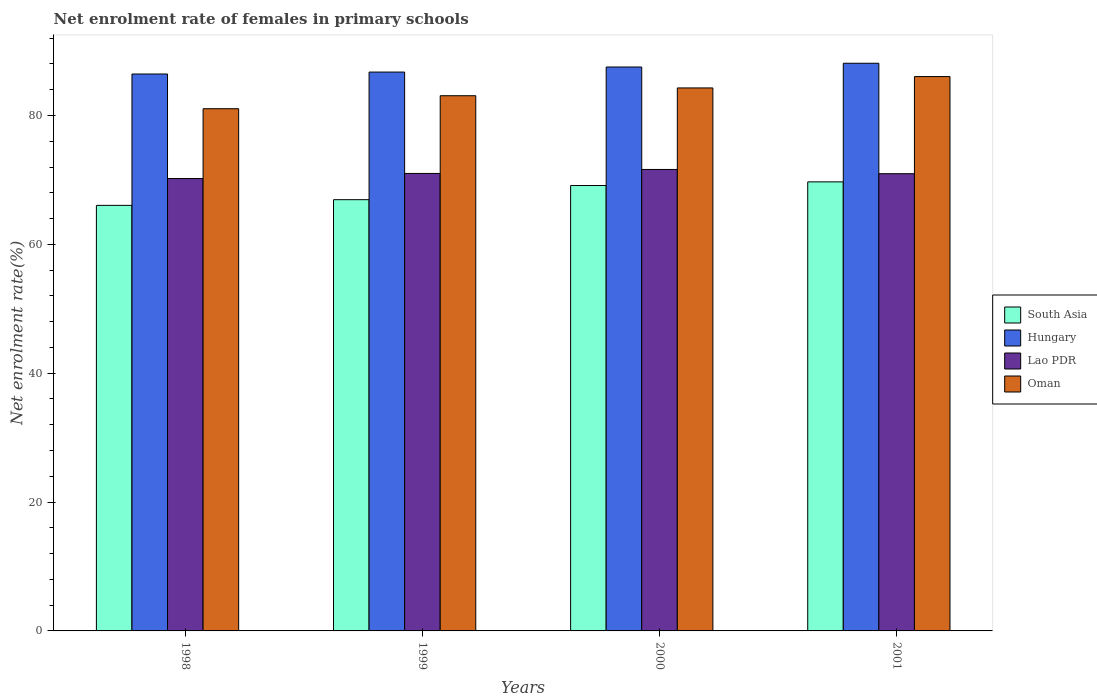How many groups of bars are there?
Keep it short and to the point. 4. Are the number of bars per tick equal to the number of legend labels?
Your response must be concise. Yes. How many bars are there on the 4th tick from the right?
Make the answer very short. 4. What is the label of the 3rd group of bars from the left?
Provide a short and direct response. 2000. In how many cases, is the number of bars for a given year not equal to the number of legend labels?
Your answer should be very brief. 0. What is the net enrolment rate of females in primary schools in Lao PDR in 2000?
Give a very brief answer. 71.62. Across all years, what is the maximum net enrolment rate of females in primary schools in South Asia?
Provide a short and direct response. 69.69. Across all years, what is the minimum net enrolment rate of females in primary schools in Hungary?
Keep it short and to the point. 86.43. What is the total net enrolment rate of females in primary schools in Oman in the graph?
Keep it short and to the point. 334.42. What is the difference between the net enrolment rate of females in primary schools in Oman in 1999 and that in 2001?
Your answer should be compact. -2.97. What is the difference between the net enrolment rate of females in primary schools in Oman in 2000 and the net enrolment rate of females in primary schools in Lao PDR in 1999?
Keep it short and to the point. 13.27. What is the average net enrolment rate of females in primary schools in South Asia per year?
Your answer should be very brief. 67.95. In the year 2000, what is the difference between the net enrolment rate of females in primary schools in Lao PDR and net enrolment rate of females in primary schools in Hungary?
Ensure brevity in your answer.  -15.9. In how many years, is the net enrolment rate of females in primary schools in Oman greater than 36 %?
Your answer should be compact. 4. What is the ratio of the net enrolment rate of females in primary schools in Hungary in 1998 to that in 2000?
Ensure brevity in your answer.  0.99. Is the net enrolment rate of females in primary schools in Lao PDR in 2000 less than that in 2001?
Offer a very short reply. No. What is the difference between the highest and the second highest net enrolment rate of females in primary schools in Hungary?
Provide a short and direct response. 0.58. What is the difference between the highest and the lowest net enrolment rate of females in primary schools in Oman?
Your answer should be compact. 4.99. Is it the case that in every year, the sum of the net enrolment rate of females in primary schools in Lao PDR and net enrolment rate of females in primary schools in Oman is greater than the sum of net enrolment rate of females in primary schools in South Asia and net enrolment rate of females in primary schools in Hungary?
Offer a very short reply. No. What does the 4th bar from the left in 2000 represents?
Give a very brief answer. Oman. What does the 2nd bar from the right in 2000 represents?
Ensure brevity in your answer.  Lao PDR. Are all the bars in the graph horizontal?
Ensure brevity in your answer.  No. How many years are there in the graph?
Ensure brevity in your answer.  4. What is the difference between two consecutive major ticks on the Y-axis?
Make the answer very short. 20. Are the values on the major ticks of Y-axis written in scientific E-notation?
Offer a terse response. No. Does the graph contain any zero values?
Give a very brief answer. No. Does the graph contain grids?
Ensure brevity in your answer.  No. Where does the legend appear in the graph?
Offer a very short reply. Center right. How many legend labels are there?
Offer a very short reply. 4. How are the legend labels stacked?
Offer a terse response. Vertical. What is the title of the graph?
Keep it short and to the point. Net enrolment rate of females in primary schools. Does "Albania" appear as one of the legend labels in the graph?
Offer a terse response. No. What is the label or title of the X-axis?
Make the answer very short. Years. What is the label or title of the Y-axis?
Your answer should be compact. Net enrolment rate(%). What is the Net enrolment rate(%) of South Asia in 1998?
Your answer should be compact. 66.05. What is the Net enrolment rate(%) in Hungary in 1998?
Give a very brief answer. 86.43. What is the Net enrolment rate(%) in Lao PDR in 1998?
Offer a very short reply. 70.21. What is the Net enrolment rate(%) of Oman in 1998?
Provide a short and direct response. 81.05. What is the Net enrolment rate(%) in South Asia in 1999?
Ensure brevity in your answer.  66.93. What is the Net enrolment rate(%) in Hungary in 1999?
Offer a terse response. 86.73. What is the Net enrolment rate(%) in Lao PDR in 1999?
Your answer should be compact. 71. What is the Net enrolment rate(%) of Oman in 1999?
Ensure brevity in your answer.  83.06. What is the Net enrolment rate(%) of South Asia in 2000?
Keep it short and to the point. 69.13. What is the Net enrolment rate(%) of Hungary in 2000?
Provide a short and direct response. 87.52. What is the Net enrolment rate(%) in Lao PDR in 2000?
Provide a short and direct response. 71.62. What is the Net enrolment rate(%) in Oman in 2000?
Ensure brevity in your answer.  84.27. What is the Net enrolment rate(%) in South Asia in 2001?
Offer a terse response. 69.69. What is the Net enrolment rate(%) of Hungary in 2001?
Offer a very short reply. 88.1. What is the Net enrolment rate(%) in Lao PDR in 2001?
Your response must be concise. 70.96. What is the Net enrolment rate(%) of Oman in 2001?
Provide a short and direct response. 86.04. Across all years, what is the maximum Net enrolment rate(%) in South Asia?
Make the answer very short. 69.69. Across all years, what is the maximum Net enrolment rate(%) in Hungary?
Your answer should be very brief. 88.1. Across all years, what is the maximum Net enrolment rate(%) in Lao PDR?
Ensure brevity in your answer.  71.62. Across all years, what is the maximum Net enrolment rate(%) in Oman?
Give a very brief answer. 86.04. Across all years, what is the minimum Net enrolment rate(%) in South Asia?
Keep it short and to the point. 66.05. Across all years, what is the minimum Net enrolment rate(%) in Hungary?
Give a very brief answer. 86.43. Across all years, what is the minimum Net enrolment rate(%) of Lao PDR?
Ensure brevity in your answer.  70.21. Across all years, what is the minimum Net enrolment rate(%) of Oman?
Make the answer very short. 81.05. What is the total Net enrolment rate(%) of South Asia in the graph?
Offer a very short reply. 271.79. What is the total Net enrolment rate(%) of Hungary in the graph?
Make the answer very short. 348.79. What is the total Net enrolment rate(%) in Lao PDR in the graph?
Your answer should be compact. 283.79. What is the total Net enrolment rate(%) in Oman in the graph?
Provide a short and direct response. 334.42. What is the difference between the Net enrolment rate(%) of South Asia in 1998 and that in 1999?
Ensure brevity in your answer.  -0.88. What is the difference between the Net enrolment rate(%) of Hungary in 1998 and that in 1999?
Give a very brief answer. -0.3. What is the difference between the Net enrolment rate(%) in Lao PDR in 1998 and that in 1999?
Give a very brief answer. -0.79. What is the difference between the Net enrolment rate(%) of Oman in 1998 and that in 1999?
Offer a terse response. -2.02. What is the difference between the Net enrolment rate(%) of South Asia in 1998 and that in 2000?
Keep it short and to the point. -3.08. What is the difference between the Net enrolment rate(%) in Hungary in 1998 and that in 2000?
Your response must be concise. -1.09. What is the difference between the Net enrolment rate(%) in Lao PDR in 1998 and that in 2000?
Your response must be concise. -1.4. What is the difference between the Net enrolment rate(%) in Oman in 1998 and that in 2000?
Make the answer very short. -3.23. What is the difference between the Net enrolment rate(%) of South Asia in 1998 and that in 2001?
Make the answer very short. -3.65. What is the difference between the Net enrolment rate(%) of Hungary in 1998 and that in 2001?
Ensure brevity in your answer.  -1.67. What is the difference between the Net enrolment rate(%) of Lao PDR in 1998 and that in 2001?
Make the answer very short. -0.75. What is the difference between the Net enrolment rate(%) in Oman in 1998 and that in 2001?
Offer a terse response. -4.99. What is the difference between the Net enrolment rate(%) in South Asia in 1999 and that in 2000?
Offer a terse response. -2.2. What is the difference between the Net enrolment rate(%) in Hungary in 1999 and that in 2000?
Your answer should be compact. -0.79. What is the difference between the Net enrolment rate(%) in Lao PDR in 1999 and that in 2000?
Your answer should be very brief. -0.62. What is the difference between the Net enrolment rate(%) in Oman in 1999 and that in 2000?
Keep it short and to the point. -1.21. What is the difference between the Net enrolment rate(%) in South Asia in 1999 and that in 2001?
Your answer should be very brief. -2.76. What is the difference between the Net enrolment rate(%) in Hungary in 1999 and that in 2001?
Make the answer very short. -1.37. What is the difference between the Net enrolment rate(%) of Lao PDR in 1999 and that in 2001?
Provide a succinct answer. 0.04. What is the difference between the Net enrolment rate(%) of Oman in 1999 and that in 2001?
Offer a very short reply. -2.97. What is the difference between the Net enrolment rate(%) of South Asia in 2000 and that in 2001?
Provide a short and direct response. -0.57. What is the difference between the Net enrolment rate(%) of Hungary in 2000 and that in 2001?
Keep it short and to the point. -0.58. What is the difference between the Net enrolment rate(%) in Lao PDR in 2000 and that in 2001?
Your answer should be very brief. 0.66. What is the difference between the Net enrolment rate(%) of Oman in 2000 and that in 2001?
Your answer should be very brief. -1.76. What is the difference between the Net enrolment rate(%) of South Asia in 1998 and the Net enrolment rate(%) of Hungary in 1999?
Offer a very short reply. -20.69. What is the difference between the Net enrolment rate(%) in South Asia in 1998 and the Net enrolment rate(%) in Lao PDR in 1999?
Your answer should be very brief. -4.96. What is the difference between the Net enrolment rate(%) of South Asia in 1998 and the Net enrolment rate(%) of Oman in 1999?
Offer a terse response. -17.02. What is the difference between the Net enrolment rate(%) of Hungary in 1998 and the Net enrolment rate(%) of Lao PDR in 1999?
Provide a short and direct response. 15.43. What is the difference between the Net enrolment rate(%) in Hungary in 1998 and the Net enrolment rate(%) in Oman in 1999?
Provide a succinct answer. 3.37. What is the difference between the Net enrolment rate(%) of Lao PDR in 1998 and the Net enrolment rate(%) of Oman in 1999?
Ensure brevity in your answer.  -12.85. What is the difference between the Net enrolment rate(%) of South Asia in 1998 and the Net enrolment rate(%) of Hungary in 2000?
Offer a terse response. -21.47. What is the difference between the Net enrolment rate(%) of South Asia in 1998 and the Net enrolment rate(%) of Lao PDR in 2000?
Make the answer very short. -5.57. What is the difference between the Net enrolment rate(%) in South Asia in 1998 and the Net enrolment rate(%) in Oman in 2000?
Give a very brief answer. -18.23. What is the difference between the Net enrolment rate(%) in Hungary in 1998 and the Net enrolment rate(%) in Lao PDR in 2000?
Give a very brief answer. 14.82. What is the difference between the Net enrolment rate(%) in Hungary in 1998 and the Net enrolment rate(%) in Oman in 2000?
Make the answer very short. 2.16. What is the difference between the Net enrolment rate(%) in Lao PDR in 1998 and the Net enrolment rate(%) in Oman in 2000?
Your answer should be compact. -14.06. What is the difference between the Net enrolment rate(%) in South Asia in 1998 and the Net enrolment rate(%) in Hungary in 2001?
Provide a short and direct response. -22.06. What is the difference between the Net enrolment rate(%) in South Asia in 1998 and the Net enrolment rate(%) in Lao PDR in 2001?
Keep it short and to the point. -4.92. What is the difference between the Net enrolment rate(%) in South Asia in 1998 and the Net enrolment rate(%) in Oman in 2001?
Your response must be concise. -19.99. What is the difference between the Net enrolment rate(%) of Hungary in 1998 and the Net enrolment rate(%) of Lao PDR in 2001?
Keep it short and to the point. 15.47. What is the difference between the Net enrolment rate(%) of Hungary in 1998 and the Net enrolment rate(%) of Oman in 2001?
Ensure brevity in your answer.  0.4. What is the difference between the Net enrolment rate(%) of Lao PDR in 1998 and the Net enrolment rate(%) of Oman in 2001?
Make the answer very short. -15.82. What is the difference between the Net enrolment rate(%) of South Asia in 1999 and the Net enrolment rate(%) of Hungary in 2000?
Your response must be concise. -20.59. What is the difference between the Net enrolment rate(%) of South Asia in 1999 and the Net enrolment rate(%) of Lao PDR in 2000?
Make the answer very short. -4.69. What is the difference between the Net enrolment rate(%) in South Asia in 1999 and the Net enrolment rate(%) in Oman in 2000?
Ensure brevity in your answer.  -17.34. What is the difference between the Net enrolment rate(%) of Hungary in 1999 and the Net enrolment rate(%) of Lao PDR in 2000?
Provide a short and direct response. 15.12. What is the difference between the Net enrolment rate(%) of Hungary in 1999 and the Net enrolment rate(%) of Oman in 2000?
Offer a very short reply. 2.46. What is the difference between the Net enrolment rate(%) in Lao PDR in 1999 and the Net enrolment rate(%) in Oman in 2000?
Keep it short and to the point. -13.27. What is the difference between the Net enrolment rate(%) in South Asia in 1999 and the Net enrolment rate(%) in Hungary in 2001?
Provide a short and direct response. -21.17. What is the difference between the Net enrolment rate(%) in South Asia in 1999 and the Net enrolment rate(%) in Lao PDR in 2001?
Provide a succinct answer. -4.03. What is the difference between the Net enrolment rate(%) in South Asia in 1999 and the Net enrolment rate(%) in Oman in 2001?
Your response must be concise. -19.11. What is the difference between the Net enrolment rate(%) in Hungary in 1999 and the Net enrolment rate(%) in Lao PDR in 2001?
Offer a very short reply. 15.77. What is the difference between the Net enrolment rate(%) in Hungary in 1999 and the Net enrolment rate(%) in Oman in 2001?
Provide a short and direct response. 0.7. What is the difference between the Net enrolment rate(%) of Lao PDR in 1999 and the Net enrolment rate(%) of Oman in 2001?
Your response must be concise. -15.04. What is the difference between the Net enrolment rate(%) in South Asia in 2000 and the Net enrolment rate(%) in Hungary in 2001?
Offer a terse response. -18.98. What is the difference between the Net enrolment rate(%) in South Asia in 2000 and the Net enrolment rate(%) in Lao PDR in 2001?
Your response must be concise. -1.84. What is the difference between the Net enrolment rate(%) of South Asia in 2000 and the Net enrolment rate(%) of Oman in 2001?
Your response must be concise. -16.91. What is the difference between the Net enrolment rate(%) in Hungary in 2000 and the Net enrolment rate(%) in Lao PDR in 2001?
Give a very brief answer. 16.56. What is the difference between the Net enrolment rate(%) in Hungary in 2000 and the Net enrolment rate(%) in Oman in 2001?
Make the answer very short. 1.48. What is the difference between the Net enrolment rate(%) of Lao PDR in 2000 and the Net enrolment rate(%) of Oman in 2001?
Ensure brevity in your answer.  -14.42. What is the average Net enrolment rate(%) of South Asia per year?
Provide a succinct answer. 67.95. What is the average Net enrolment rate(%) of Hungary per year?
Provide a short and direct response. 87.2. What is the average Net enrolment rate(%) of Lao PDR per year?
Ensure brevity in your answer.  70.95. What is the average Net enrolment rate(%) in Oman per year?
Make the answer very short. 83.6. In the year 1998, what is the difference between the Net enrolment rate(%) of South Asia and Net enrolment rate(%) of Hungary?
Provide a short and direct response. -20.39. In the year 1998, what is the difference between the Net enrolment rate(%) of South Asia and Net enrolment rate(%) of Lao PDR?
Your answer should be very brief. -4.17. In the year 1998, what is the difference between the Net enrolment rate(%) of South Asia and Net enrolment rate(%) of Oman?
Keep it short and to the point. -15. In the year 1998, what is the difference between the Net enrolment rate(%) in Hungary and Net enrolment rate(%) in Lao PDR?
Offer a terse response. 16.22. In the year 1998, what is the difference between the Net enrolment rate(%) in Hungary and Net enrolment rate(%) in Oman?
Your answer should be compact. 5.39. In the year 1998, what is the difference between the Net enrolment rate(%) in Lao PDR and Net enrolment rate(%) in Oman?
Your response must be concise. -10.83. In the year 1999, what is the difference between the Net enrolment rate(%) of South Asia and Net enrolment rate(%) of Hungary?
Offer a very short reply. -19.8. In the year 1999, what is the difference between the Net enrolment rate(%) of South Asia and Net enrolment rate(%) of Lao PDR?
Provide a succinct answer. -4.07. In the year 1999, what is the difference between the Net enrolment rate(%) in South Asia and Net enrolment rate(%) in Oman?
Offer a very short reply. -16.13. In the year 1999, what is the difference between the Net enrolment rate(%) of Hungary and Net enrolment rate(%) of Lao PDR?
Give a very brief answer. 15.73. In the year 1999, what is the difference between the Net enrolment rate(%) in Hungary and Net enrolment rate(%) in Oman?
Provide a succinct answer. 3.67. In the year 1999, what is the difference between the Net enrolment rate(%) of Lao PDR and Net enrolment rate(%) of Oman?
Your answer should be compact. -12.06. In the year 2000, what is the difference between the Net enrolment rate(%) in South Asia and Net enrolment rate(%) in Hungary?
Your response must be concise. -18.39. In the year 2000, what is the difference between the Net enrolment rate(%) in South Asia and Net enrolment rate(%) in Lao PDR?
Keep it short and to the point. -2.49. In the year 2000, what is the difference between the Net enrolment rate(%) of South Asia and Net enrolment rate(%) of Oman?
Your answer should be compact. -15.15. In the year 2000, what is the difference between the Net enrolment rate(%) of Hungary and Net enrolment rate(%) of Lao PDR?
Provide a succinct answer. 15.9. In the year 2000, what is the difference between the Net enrolment rate(%) in Hungary and Net enrolment rate(%) in Oman?
Keep it short and to the point. 3.25. In the year 2000, what is the difference between the Net enrolment rate(%) of Lao PDR and Net enrolment rate(%) of Oman?
Your answer should be compact. -12.65. In the year 2001, what is the difference between the Net enrolment rate(%) in South Asia and Net enrolment rate(%) in Hungary?
Provide a short and direct response. -18.41. In the year 2001, what is the difference between the Net enrolment rate(%) in South Asia and Net enrolment rate(%) in Lao PDR?
Provide a succinct answer. -1.27. In the year 2001, what is the difference between the Net enrolment rate(%) of South Asia and Net enrolment rate(%) of Oman?
Keep it short and to the point. -16.34. In the year 2001, what is the difference between the Net enrolment rate(%) in Hungary and Net enrolment rate(%) in Lao PDR?
Offer a terse response. 17.14. In the year 2001, what is the difference between the Net enrolment rate(%) of Hungary and Net enrolment rate(%) of Oman?
Provide a succinct answer. 2.06. In the year 2001, what is the difference between the Net enrolment rate(%) in Lao PDR and Net enrolment rate(%) in Oman?
Your answer should be very brief. -15.08. What is the ratio of the Net enrolment rate(%) in Hungary in 1998 to that in 1999?
Offer a very short reply. 1. What is the ratio of the Net enrolment rate(%) in Lao PDR in 1998 to that in 1999?
Provide a succinct answer. 0.99. What is the ratio of the Net enrolment rate(%) in Oman in 1998 to that in 1999?
Give a very brief answer. 0.98. What is the ratio of the Net enrolment rate(%) of South Asia in 1998 to that in 2000?
Make the answer very short. 0.96. What is the ratio of the Net enrolment rate(%) in Hungary in 1998 to that in 2000?
Your answer should be very brief. 0.99. What is the ratio of the Net enrolment rate(%) in Lao PDR in 1998 to that in 2000?
Ensure brevity in your answer.  0.98. What is the ratio of the Net enrolment rate(%) in Oman in 1998 to that in 2000?
Give a very brief answer. 0.96. What is the ratio of the Net enrolment rate(%) in South Asia in 1998 to that in 2001?
Make the answer very short. 0.95. What is the ratio of the Net enrolment rate(%) of Hungary in 1998 to that in 2001?
Make the answer very short. 0.98. What is the ratio of the Net enrolment rate(%) in Lao PDR in 1998 to that in 2001?
Keep it short and to the point. 0.99. What is the ratio of the Net enrolment rate(%) in Oman in 1998 to that in 2001?
Ensure brevity in your answer.  0.94. What is the ratio of the Net enrolment rate(%) in South Asia in 1999 to that in 2000?
Your answer should be very brief. 0.97. What is the ratio of the Net enrolment rate(%) of Lao PDR in 1999 to that in 2000?
Offer a very short reply. 0.99. What is the ratio of the Net enrolment rate(%) in Oman in 1999 to that in 2000?
Give a very brief answer. 0.99. What is the ratio of the Net enrolment rate(%) in South Asia in 1999 to that in 2001?
Ensure brevity in your answer.  0.96. What is the ratio of the Net enrolment rate(%) in Hungary in 1999 to that in 2001?
Provide a succinct answer. 0.98. What is the ratio of the Net enrolment rate(%) of Lao PDR in 1999 to that in 2001?
Give a very brief answer. 1. What is the ratio of the Net enrolment rate(%) of Oman in 1999 to that in 2001?
Offer a terse response. 0.97. What is the ratio of the Net enrolment rate(%) in Lao PDR in 2000 to that in 2001?
Offer a very short reply. 1.01. What is the ratio of the Net enrolment rate(%) of Oman in 2000 to that in 2001?
Your answer should be very brief. 0.98. What is the difference between the highest and the second highest Net enrolment rate(%) in South Asia?
Your answer should be compact. 0.57. What is the difference between the highest and the second highest Net enrolment rate(%) in Hungary?
Keep it short and to the point. 0.58. What is the difference between the highest and the second highest Net enrolment rate(%) of Lao PDR?
Provide a short and direct response. 0.62. What is the difference between the highest and the second highest Net enrolment rate(%) of Oman?
Your response must be concise. 1.76. What is the difference between the highest and the lowest Net enrolment rate(%) in South Asia?
Offer a terse response. 3.65. What is the difference between the highest and the lowest Net enrolment rate(%) in Hungary?
Offer a very short reply. 1.67. What is the difference between the highest and the lowest Net enrolment rate(%) in Lao PDR?
Keep it short and to the point. 1.4. What is the difference between the highest and the lowest Net enrolment rate(%) of Oman?
Give a very brief answer. 4.99. 